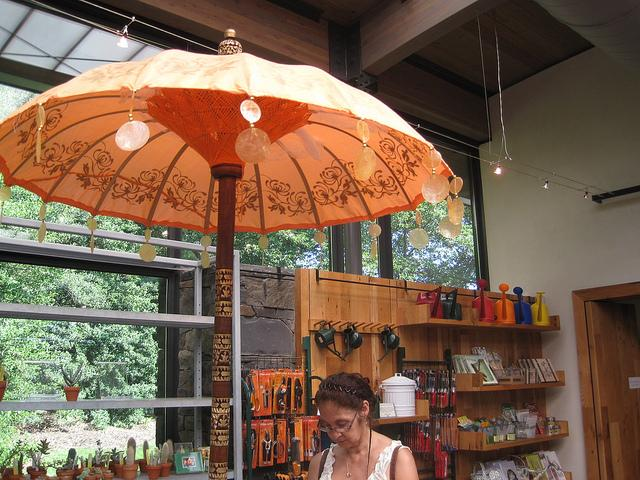What type of shop is this? Please explain your reasoning. gift. The shelves are decorated with random gifts and small souvenirs, which indicates that this location is a gift shop. 